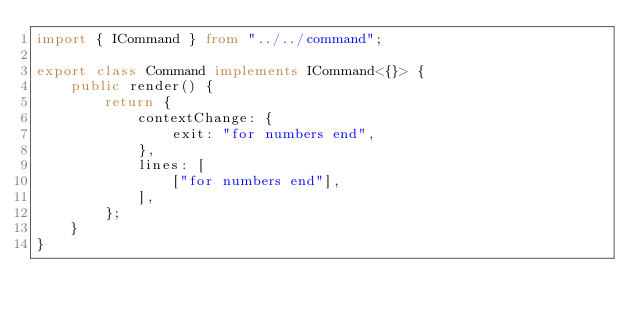<code> <loc_0><loc_0><loc_500><loc_500><_TypeScript_>import { ICommand } from "../../command";

export class Command implements ICommand<{}> {
    public render() {
        return {
            contextChange: {
                exit: "for numbers end",
            },
            lines: [
                ["for numbers end"],
            ],
        };
    }
}
</code> 